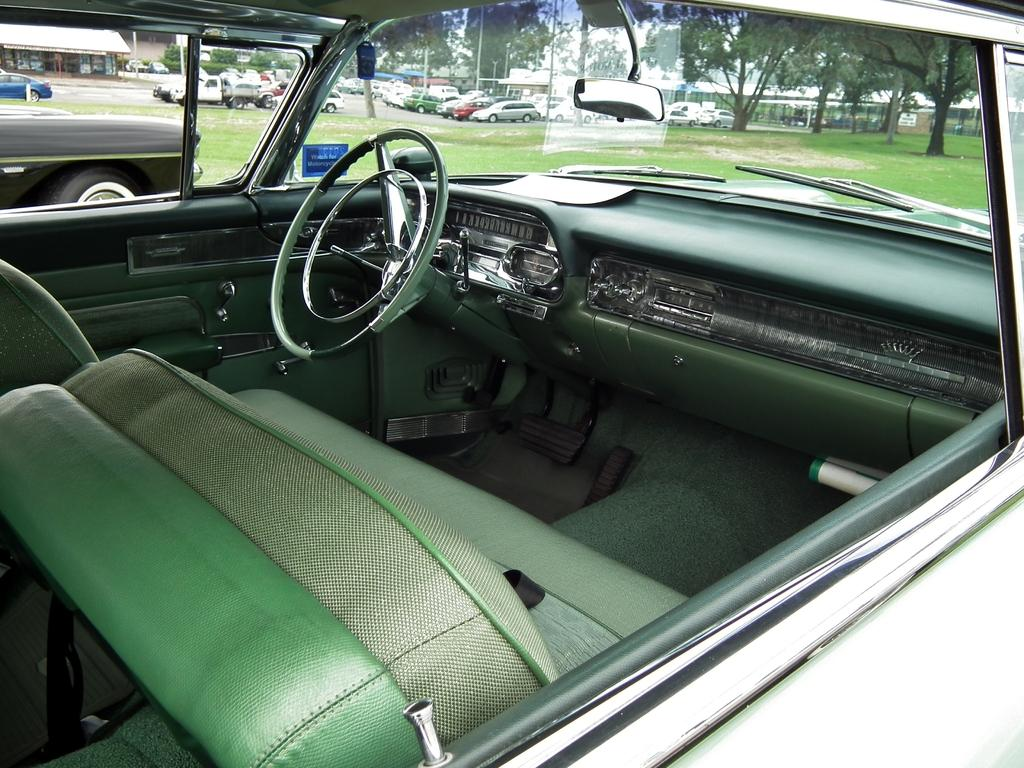What type of setting is depicted in the image? The image shows an inside view of a car. What can be seen outside the car in the image? There are vehicles visible in the background, as well as grass and trees. What is located on the left side of the image? There is a store on the left side of the image. What type of glove is being discussed by the committee in the image? There is no committee or glove present in the image; it shows an inside view of a car with a view of the outside environment and a store on the left side. 